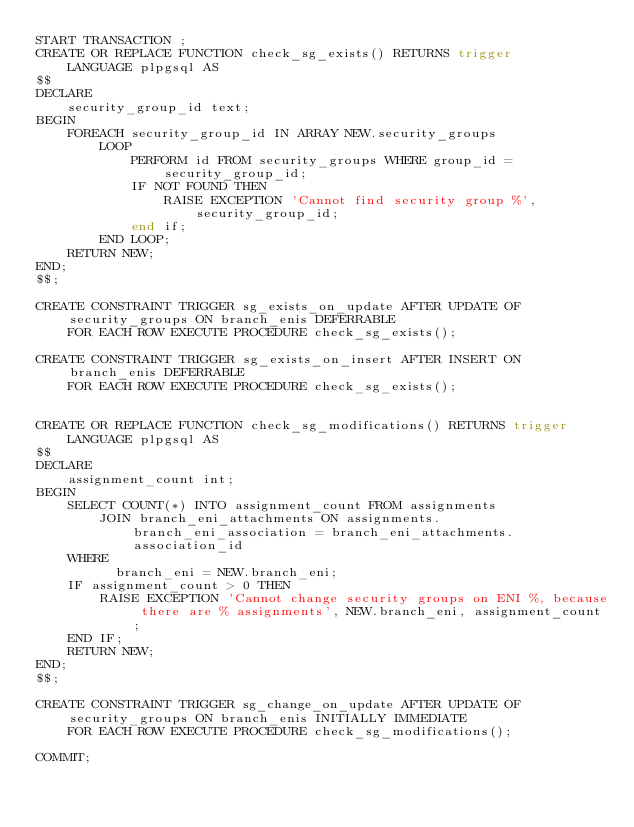<code> <loc_0><loc_0><loc_500><loc_500><_SQL_>START TRANSACTION ;
CREATE OR REPLACE FUNCTION check_sg_exists() RETURNS trigger
    LANGUAGE plpgsql AS
$$
DECLARE
    security_group_id text;
BEGIN
    FOREACH security_group_id IN ARRAY NEW.security_groups
        LOOP
            PERFORM id FROM security_groups WHERE group_id = security_group_id;
            IF NOT FOUND THEN
                RAISE EXCEPTION 'Cannot find security group %', security_group_id;
            end if;
        END LOOP;
    RETURN NEW;
END;
$$;

CREATE CONSTRAINT TRIGGER sg_exists_on_update AFTER UPDATE OF security_groups ON branch_enis DEFERRABLE
    FOR EACH ROW EXECUTE PROCEDURE check_sg_exists();

CREATE CONSTRAINT TRIGGER sg_exists_on_insert AFTER INSERT ON branch_enis DEFERRABLE
    FOR EACH ROW EXECUTE PROCEDURE check_sg_exists();


CREATE OR REPLACE FUNCTION check_sg_modifications() RETURNS trigger
    LANGUAGE plpgsql AS
$$
DECLARE
    assignment_count int;
BEGIN
    SELECT COUNT(*) INTO assignment_count FROM assignments
        JOIN branch_eni_attachments ON assignments.branch_eni_association = branch_eni_attachments.association_id
    WHERE
          branch_eni = NEW.branch_eni;
    IF assignment_count > 0 THEN
        RAISE EXCEPTION 'Cannot change security groups on ENI %, because there are % assignments', NEW.branch_eni, assignment_count;
    END IF;
    RETURN NEW;
END;
$$;

CREATE CONSTRAINT TRIGGER sg_change_on_update AFTER UPDATE OF security_groups ON branch_enis INITIALLY IMMEDIATE
    FOR EACH ROW EXECUTE PROCEDURE check_sg_modifications();

COMMIT;
</code> 